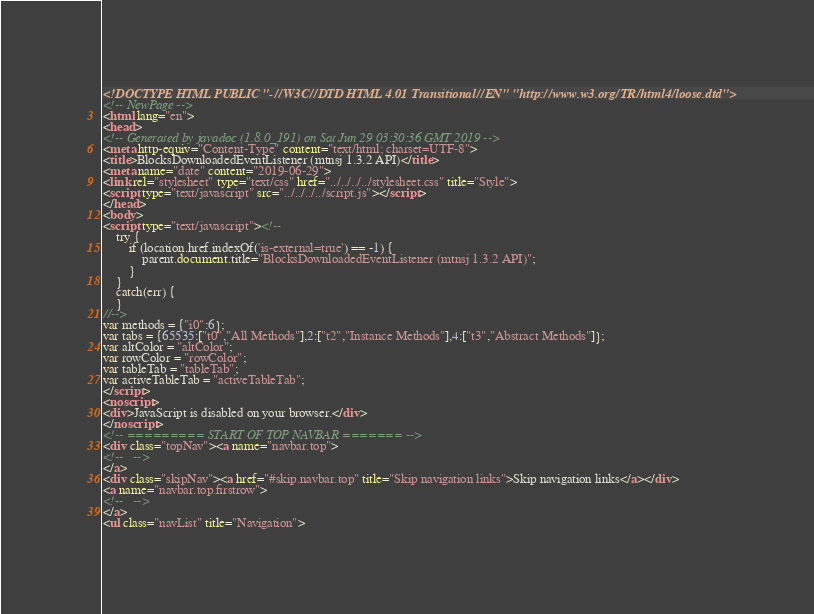Convert code to text. <code><loc_0><loc_0><loc_500><loc_500><_HTML_><!DOCTYPE HTML PUBLIC "-//W3C//DTD HTML 4.01 Transitional//EN" "http://www.w3.org/TR/html4/loose.dtd">
<!-- NewPage -->
<html lang="en">
<head>
<!-- Generated by javadoc (1.8.0_191) on Sat Jun 29 03:30:36 GMT 2019 -->
<meta http-equiv="Content-Type" content="text/html; charset=UTF-8">
<title>BlocksDownloadedEventListener (mtnsj 1.3.2 API)</title>
<meta name="date" content="2019-06-29">
<link rel="stylesheet" type="text/css" href="../../../../stylesheet.css" title="Style">
<script type="text/javascript" src="../../../../script.js"></script>
</head>
<body>
<script type="text/javascript"><!--
    try {
        if (location.href.indexOf('is-external=true') == -1) {
            parent.document.title="BlocksDownloadedEventListener (mtnsj 1.3.2 API)";
        }
    }
    catch(err) {
    }
//-->
var methods = {"i0":6};
var tabs = {65535:["t0","All Methods"],2:["t2","Instance Methods"],4:["t3","Abstract Methods"]};
var altColor = "altColor";
var rowColor = "rowColor";
var tableTab = "tableTab";
var activeTableTab = "activeTableTab";
</script>
<noscript>
<div>JavaScript is disabled on your browser.</div>
</noscript>
<!-- ========= START OF TOP NAVBAR ======= -->
<div class="topNav"><a name="navbar.top">
<!--   -->
</a>
<div class="skipNav"><a href="#skip.navbar.top" title="Skip navigation links">Skip navigation links</a></div>
<a name="navbar.top.firstrow">
<!--   -->
</a>
<ul class="navList" title="Navigation"></code> 